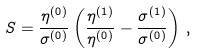Convert formula to latex. <formula><loc_0><loc_0><loc_500><loc_500>S = \frac { \eta ^ { ( 0 ) } } { \sigma ^ { ( 0 ) } } \left ( \frac { \eta ^ { ( 1 ) } } { \eta ^ { ( 0 ) } } - \frac { \sigma ^ { ( 1 ) } } { \sigma ^ { ( 0 ) } } \right ) \, ,</formula> 